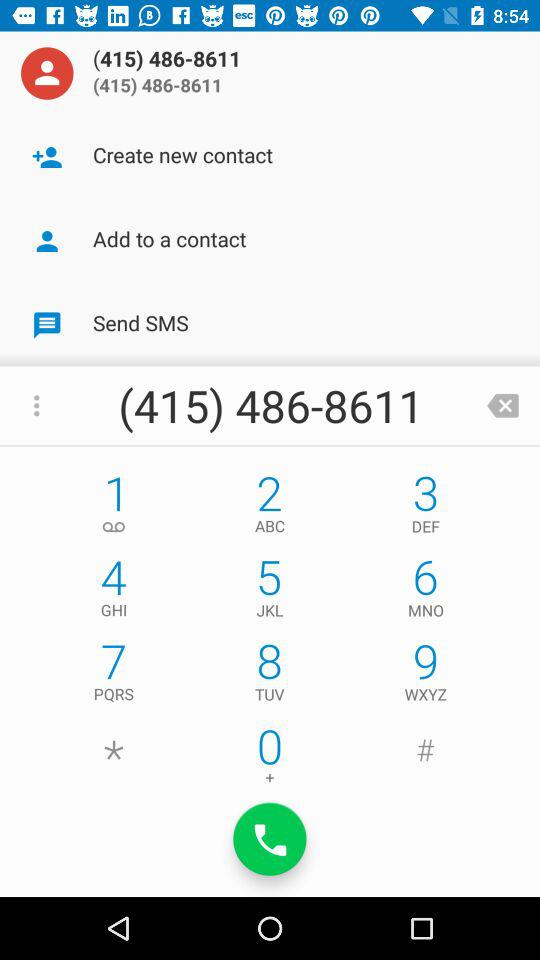What is the dialled phone number? The dialled phone number is (415) 486-8611. 